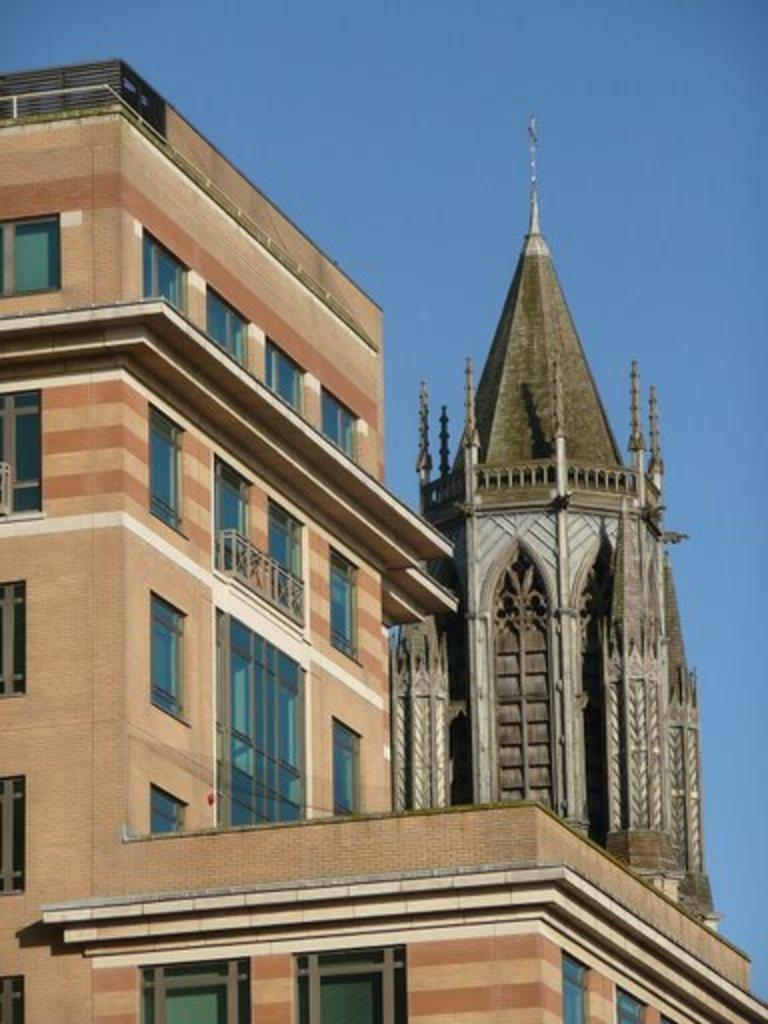What type of structure is present in the image? There is a building in the image. What additional feature can be seen in the image? There is a tower in the image. What part of the natural environment is visible in the image? The sky is visible in the image. What type of drink is being served in the image? There is no drink present in the image; it features a building and a tower. What part of the structure is made of cord in the image? There is no part of the structure made of cord in the image. 